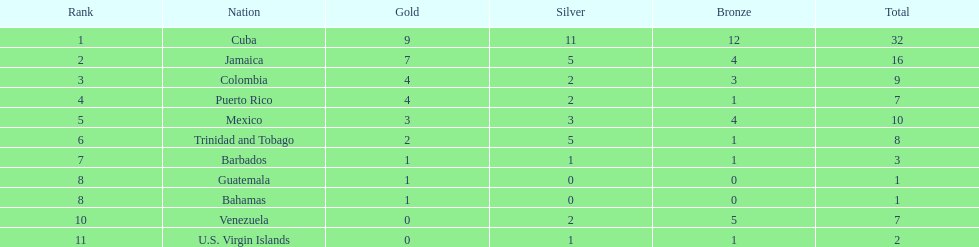Greatest medal disparity among countries 31. 